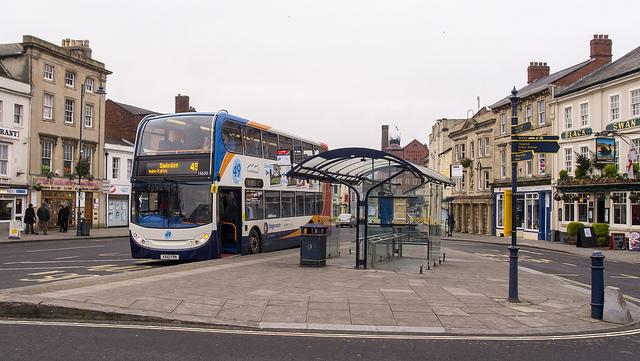What is the round blue bin used to collect?

Choices:
A) candy
B) mail
C) rain
D) trash trash 